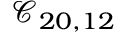Convert formula to latex. <formula><loc_0><loc_0><loc_500><loc_500>\mathcal { C } _ { 2 0 , 1 2 }</formula> 